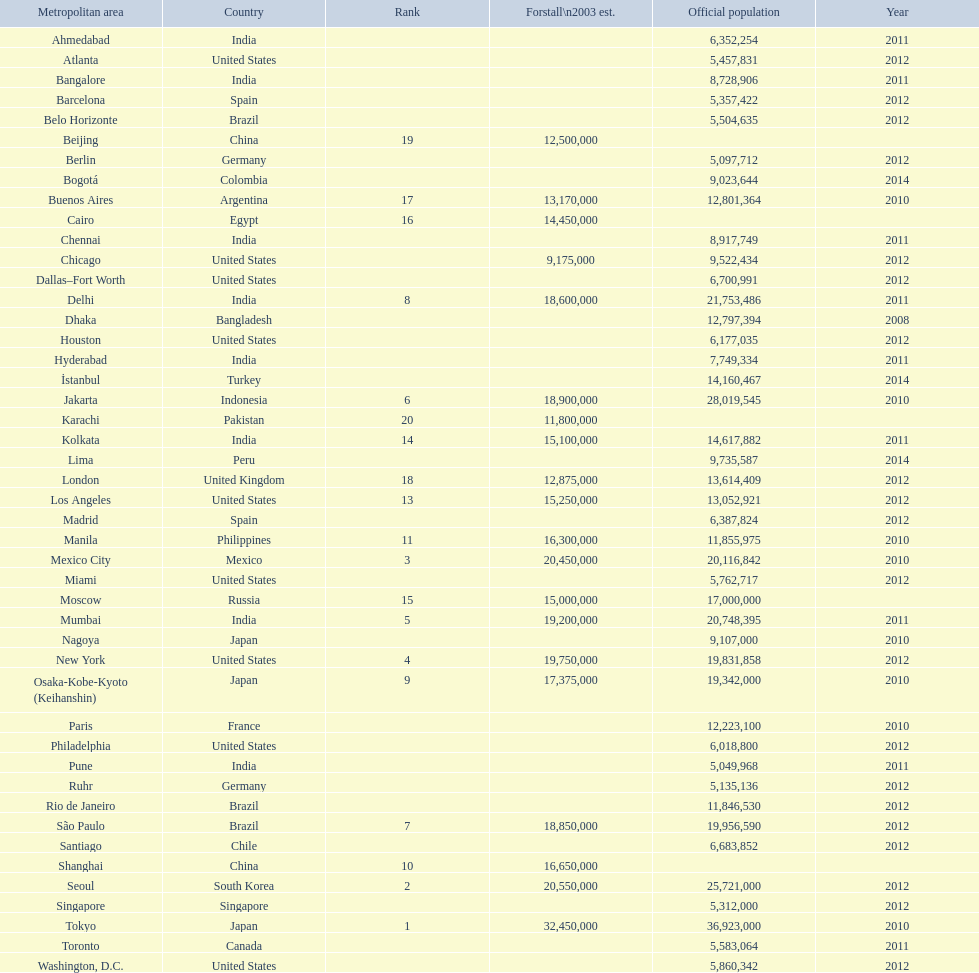Which population is listed before 5,357,422? 8,728,906. 